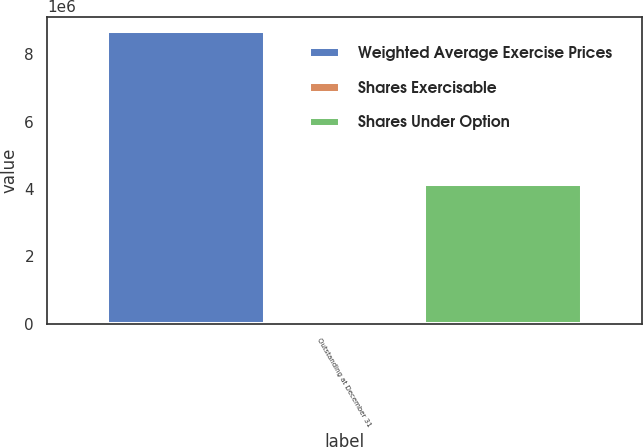Convert chart to OTSL. <chart><loc_0><loc_0><loc_500><loc_500><stacked_bar_chart><ecel><fcel>Outstanding at December 31<nl><fcel>Weighted Average Exercise Prices<fcel>8.68495e+06<nl><fcel>Shares Exercisable<fcel>76.89<nl><fcel>Shares Under Option<fcel>4.15956e+06<nl></chart> 